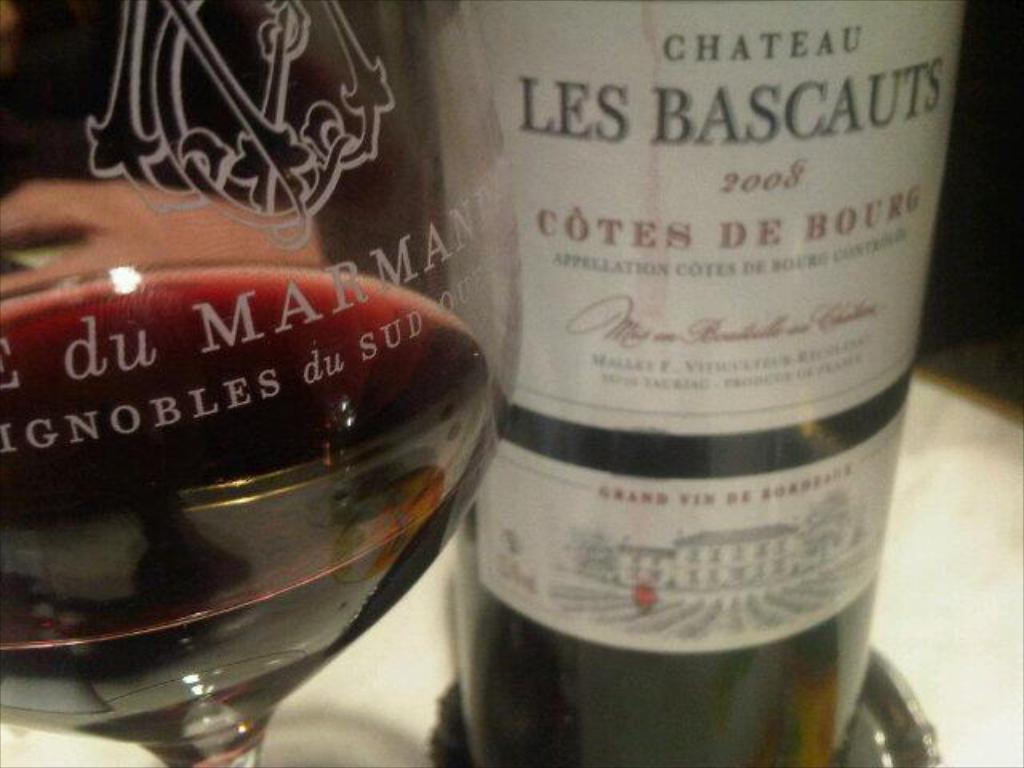What is the main object in the center of the image? There is a glass in the center of the image. What other object can be seen in the image? There is a bottle in the image. What is written on the glass? There are texts written on the glass. What is written on the bottle? There are texts written on the bottle. What type of wound can be seen on the page in the image? There is no page or wound present in the image. 